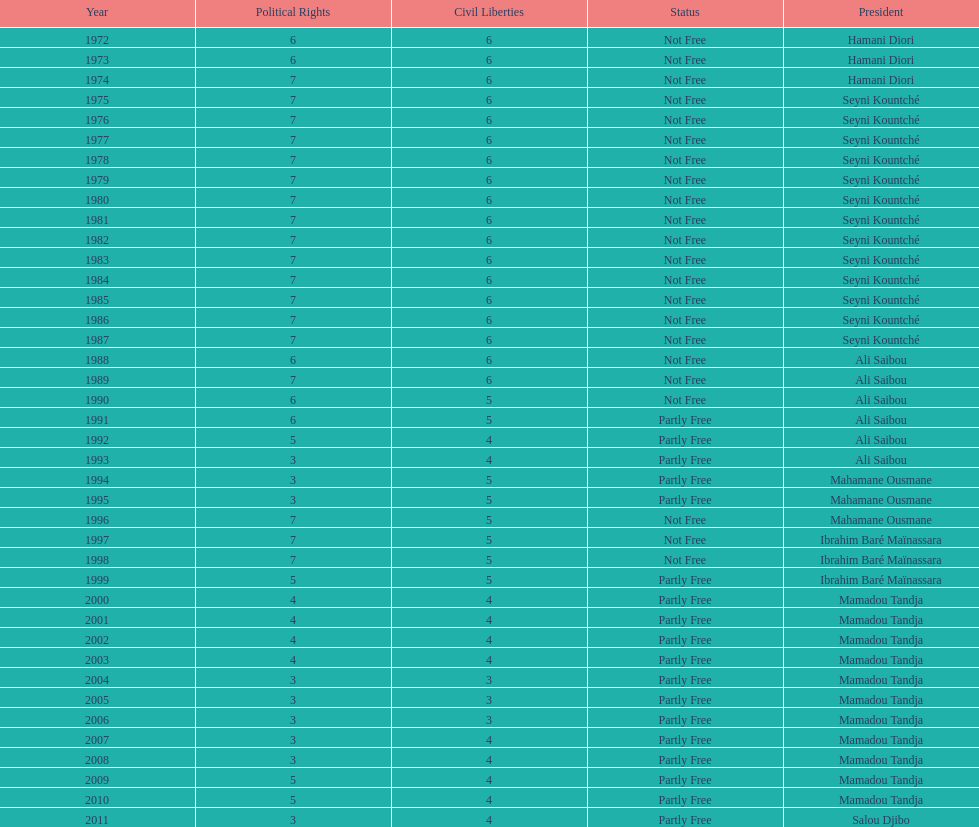In how many cases were the political rights mentioned as seven? 18. 